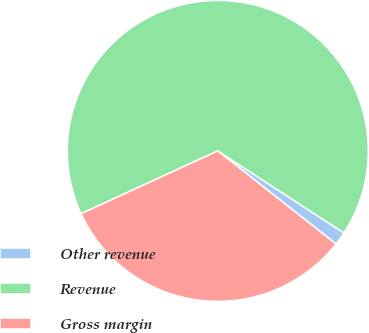<chart> <loc_0><loc_0><loc_500><loc_500><pie_chart><fcel>Other revenue<fcel>Revenue<fcel>Gross margin<nl><fcel>1.44%<fcel>66.04%<fcel>32.53%<nl></chart> 